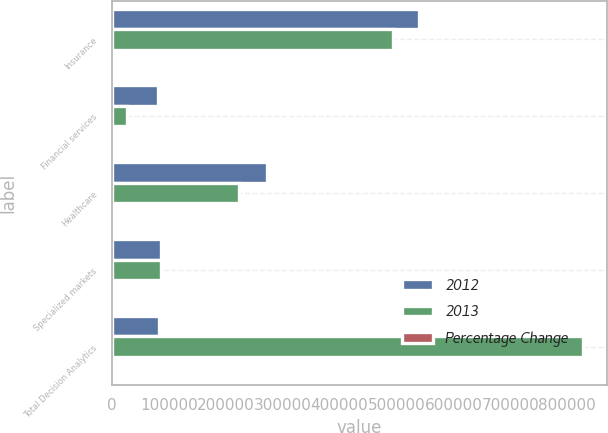<chart> <loc_0><loc_0><loc_500><loc_500><stacked_bar_chart><ecel><fcel>Insurance<fcel>Financial services<fcel>Healthcare<fcel>Specialized markets<fcel>Total Decision Analytics<nl><fcel>2012<fcel>539150<fcel>81113<fcel>271538<fcel>85626<fcel>83238.5<nl><fcel>2013<fcel>493456<fcel>26567<fcel>222955<fcel>85364<fcel>828342<nl><fcel>Percentage Change<fcel>9.3<fcel>205.3<fcel>21.8<fcel>0.3<fcel>18<nl></chart> 